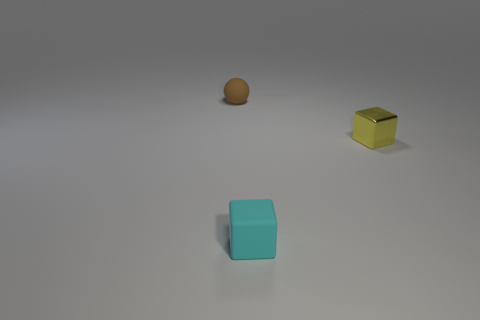Subtract 1 blocks. How many blocks are left? 1 Subtract all yellow blocks. How many blocks are left? 1 Add 2 large blue rubber cylinders. How many objects exist? 5 Subtract all spheres. How many objects are left? 2 Subtract all gray blocks. Subtract all purple spheres. How many blocks are left? 2 Subtract all brown balls. How many cyan blocks are left? 1 Subtract all cyan spheres. Subtract all small yellow things. How many objects are left? 2 Add 1 matte spheres. How many matte spheres are left? 2 Add 2 green cubes. How many green cubes exist? 2 Subtract 1 yellow blocks. How many objects are left? 2 